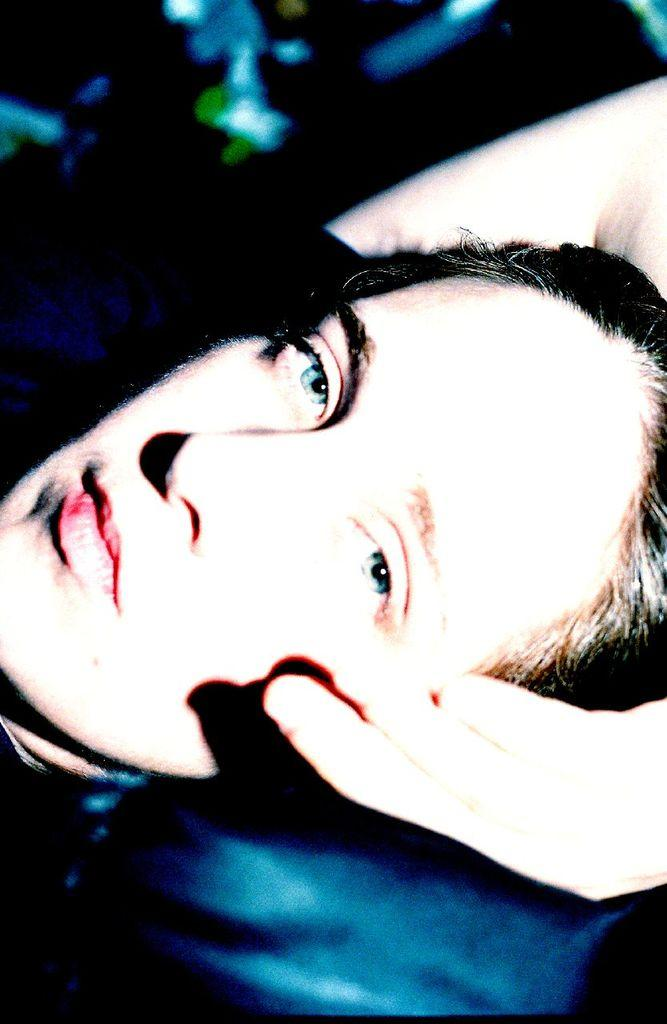What is the main subject of the image? There is a woman's face in the image. What else can be seen in the image besides the woman's face? There is a hand in the image. How would you describe the background of the image? The background of the image is blurry. What type of key is being used to open the market in the image? There is no key or market present in the image; it only features a woman's face and a hand. 